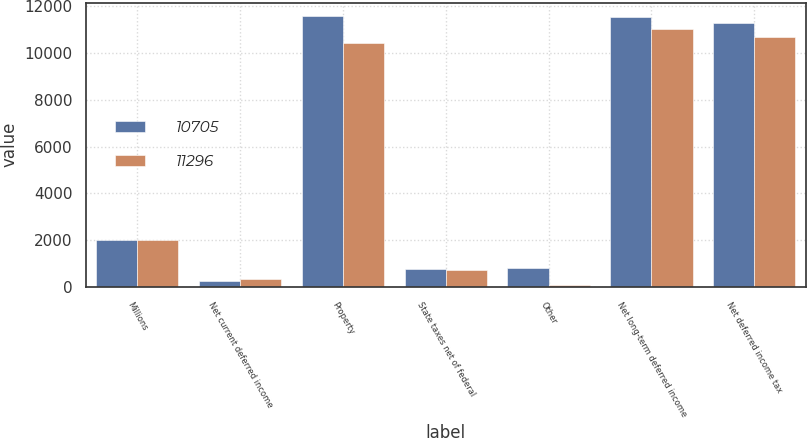<chart> <loc_0><loc_0><loc_500><loc_500><stacked_bar_chart><ecel><fcel>Millions<fcel>Net current deferred income<fcel>Property<fcel>State taxes net of federal<fcel>Other<fcel>Net long-term deferred income<fcel>Net deferred income tax<nl><fcel>10705<fcel>2010<fcel>261<fcel>11581<fcel>772<fcel>796<fcel>11557<fcel>11296<nl><fcel>11296<fcel>2009<fcel>339<fcel>10419<fcel>715<fcel>90<fcel>11044<fcel>10705<nl></chart> 